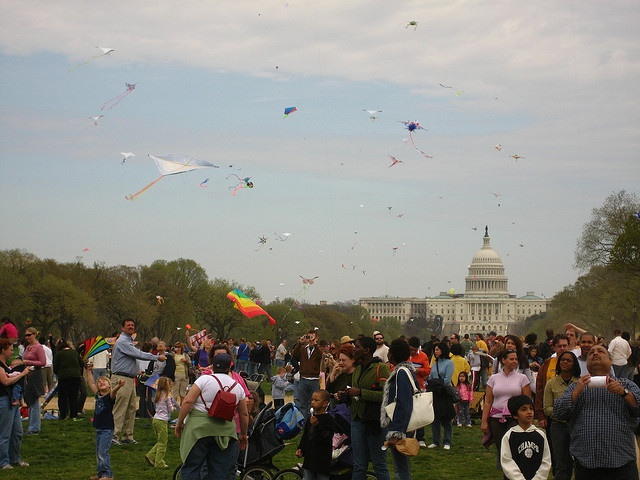Describe the objects in this image and their specific colors. I can see people in lightgray, black, maroon, and gray tones, people in lightgray, black, darkgreen, maroon, and gray tones, kite in lightgray and darkgray tones, people in lightgray, gray, and black tones, and people in lightgray, black, maroon, darkgray, and gray tones in this image. 